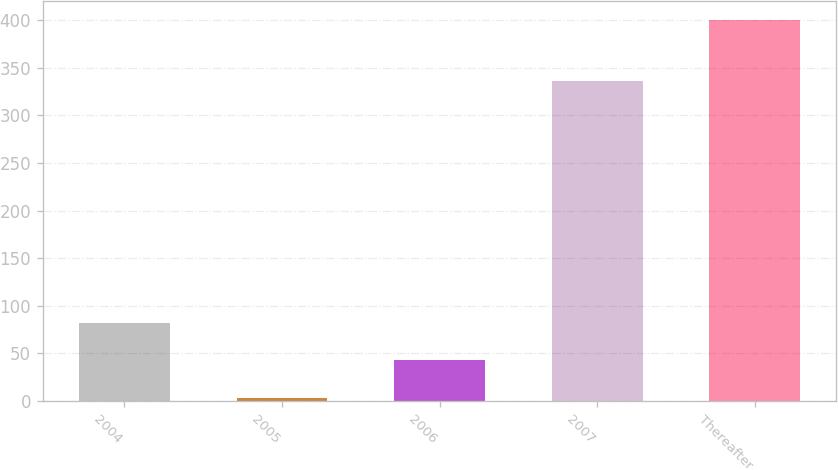Convert chart to OTSL. <chart><loc_0><loc_0><loc_500><loc_500><bar_chart><fcel>2004<fcel>2005<fcel>2006<fcel>2007<fcel>Thereafter<nl><fcel>82.4<fcel>3<fcel>42.7<fcel>336<fcel>400<nl></chart> 